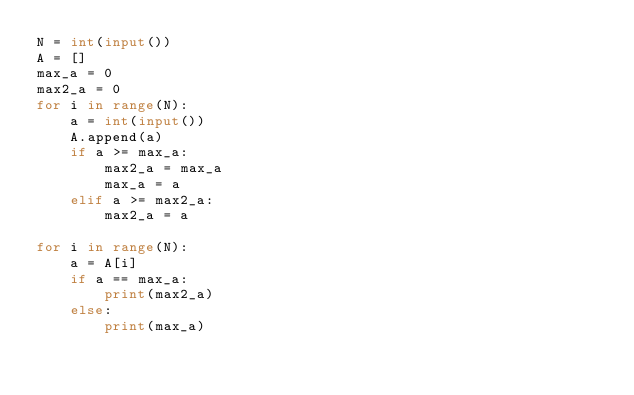<code> <loc_0><loc_0><loc_500><loc_500><_Python_>N = int(input())
A = []
max_a = 0
max2_a = 0
for i in range(N):
	a = int(input())
	A.append(a)
	if a >= max_a:
		max2_a = max_a
		max_a = a
	elif a >= max2_a:
		max2_a = a

for i in range(N):
	a = A[i]
	if a == max_a:
		print(max2_a)
	else:
		print(max_a)
</code> 